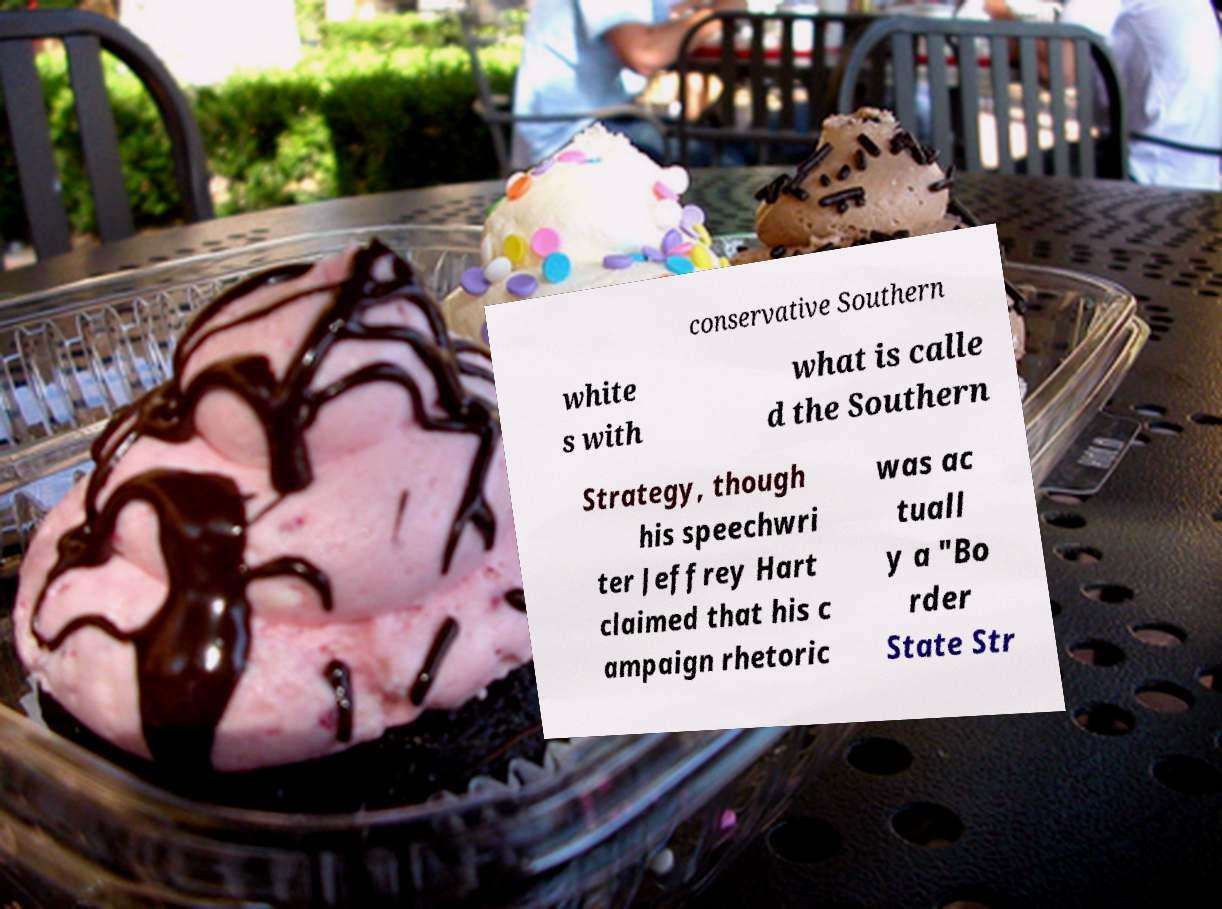Can you read and provide the text displayed in the image?This photo seems to have some interesting text. Can you extract and type it out for me? conservative Southern white s with what is calle d the Southern Strategy, though his speechwri ter Jeffrey Hart claimed that his c ampaign rhetoric was ac tuall y a "Bo rder State Str 